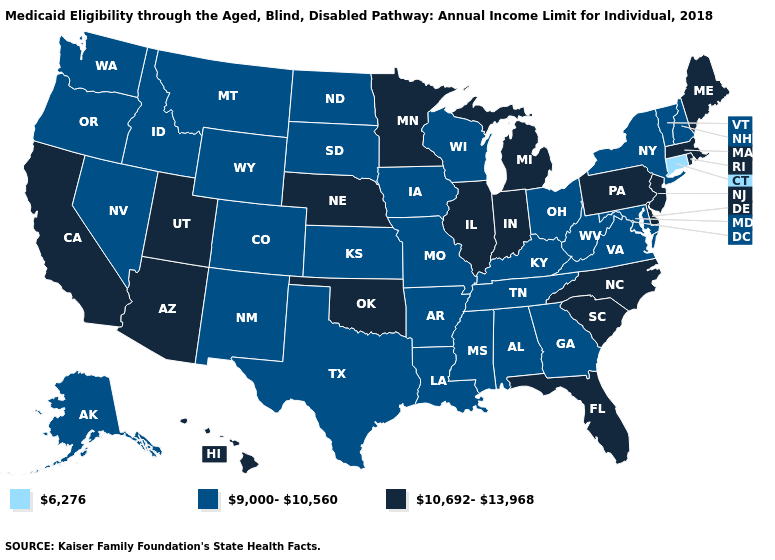Does Oregon have the lowest value in the West?
Quick response, please. Yes. What is the value of Delaware?
Answer briefly. 10,692-13,968. Does Oklahoma have the lowest value in the South?
Give a very brief answer. No. Does Maine have the same value as North Carolina?
Keep it brief. Yes. Name the states that have a value in the range 9,000-10,560?
Quick response, please. Alabama, Alaska, Arkansas, Colorado, Georgia, Idaho, Iowa, Kansas, Kentucky, Louisiana, Maryland, Mississippi, Missouri, Montana, Nevada, New Hampshire, New Mexico, New York, North Dakota, Ohio, Oregon, South Dakota, Tennessee, Texas, Vermont, Virginia, Washington, West Virginia, Wisconsin, Wyoming. Is the legend a continuous bar?
Keep it brief. No. Name the states that have a value in the range 9,000-10,560?
Write a very short answer. Alabama, Alaska, Arkansas, Colorado, Georgia, Idaho, Iowa, Kansas, Kentucky, Louisiana, Maryland, Mississippi, Missouri, Montana, Nevada, New Hampshire, New Mexico, New York, North Dakota, Ohio, Oregon, South Dakota, Tennessee, Texas, Vermont, Virginia, Washington, West Virginia, Wisconsin, Wyoming. Name the states that have a value in the range 6,276?
Answer briefly. Connecticut. What is the value of Indiana?
Be succinct. 10,692-13,968. What is the highest value in the USA?
Short answer required. 10,692-13,968. Does Kentucky have the highest value in the South?
Give a very brief answer. No. Which states have the lowest value in the South?
Short answer required. Alabama, Arkansas, Georgia, Kentucky, Louisiana, Maryland, Mississippi, Tennessee, Texas, Virginia, West Virginia. Name the states that have a value in the range 9,000-10,560?
Short answer required. Alabama, Alaska, Arkansas, Colorado, Georgia, Idaho, Iowa, Kansas, Kentucky, Louisiana, Maryland, Mississippi, Missouri, Montana, Nevada, New Hampshire, New Mexico, New York, North Dakota, Ohio, Oregon, South Dakota, Tennessee, Texas, Vermont, Virginia, Washington, West Virginia, Wisconsin, Wyoming. 